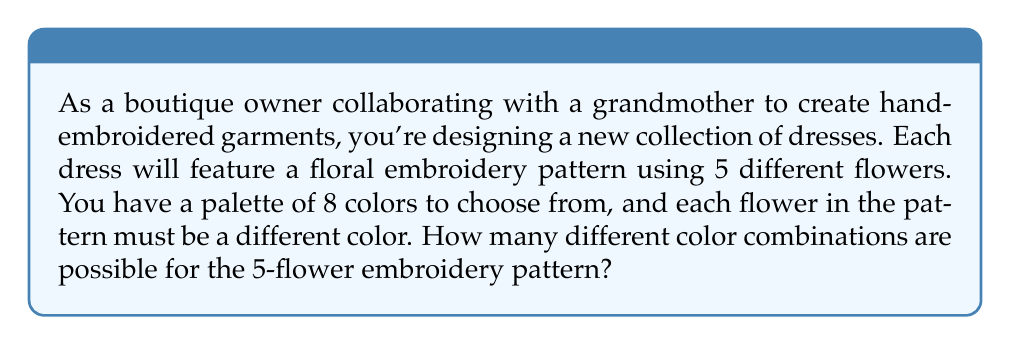Could you help me with this problem? To solve this problem, we need to use the concept of permutations. Here's a step-by-step explanation:

1. We have 8 colors to choose from for the first flower.
2. After using one color, we have 7 colors left for the second flower.
3. For the third flower, we have 6 colors remaining.
4. For the fourth flower, we have 5 colors left.
5. For the last flower, we have 4 colors to choose from.

This scenario is a perfect example of permutations without repetition. The formula for permutations without repetition is:

$$P(n,r) = \frac{n!}{(n-r)!}$$

Where:
$n$ = total number of items to choose from
$r$ = number of items being chosen

In our case:
$n = 8$ (total colors)
$r = 5$ (flowers in the pattern)

Let's apply the formula:

$$P(8,5) = \frac{8!}{(8-5)!} = \frac{8!}{3!}$$

Expanding this:

$$\frac{8 \times 7 \times 6 \times 5 \times 4 \times 3!}{3!}$$

The $3!$ cancels out in the numerator and denominator:

$$8 \times 7 \times 6 \times 5 \times 4 = 6720$$

Therefore, there are 6720 possible color combinations for the 5-flower embroidery pattern.
Answer: 6720 color combinations 